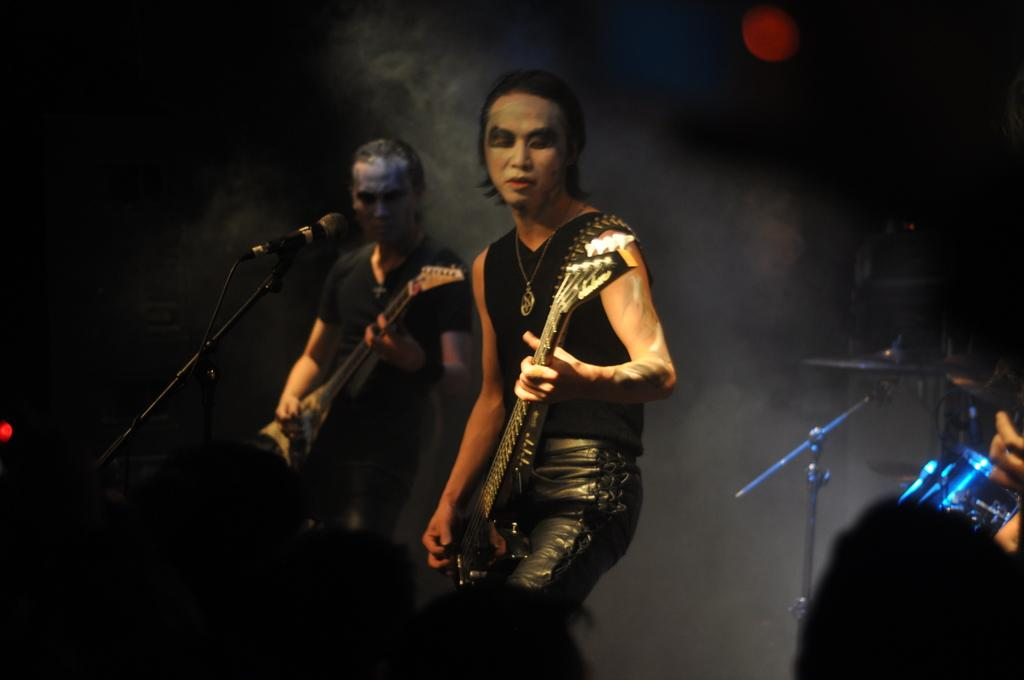What activity are the two people in the image engaged in? The two people in the image are playing musical instruments. What can be seen at the bottom of the image? Human heads are visible at the bottom of the image. What device is used for amplifying sound in the image? A microphone is present in the image. What type of object is present in the image that connects various components? There are wires in the image. Where is the musical instrument located in the image? There is a musical instrument on the right side of the image. What type of sky is visible in the image? There is no sky visible in the image; it is an indoor setting. How many partners are involved in the musical performance in the image? The question of "partners" is not applicable in this context, as the focus is on the musical instruments and not on any partnerships or relationships between the people in the image. 